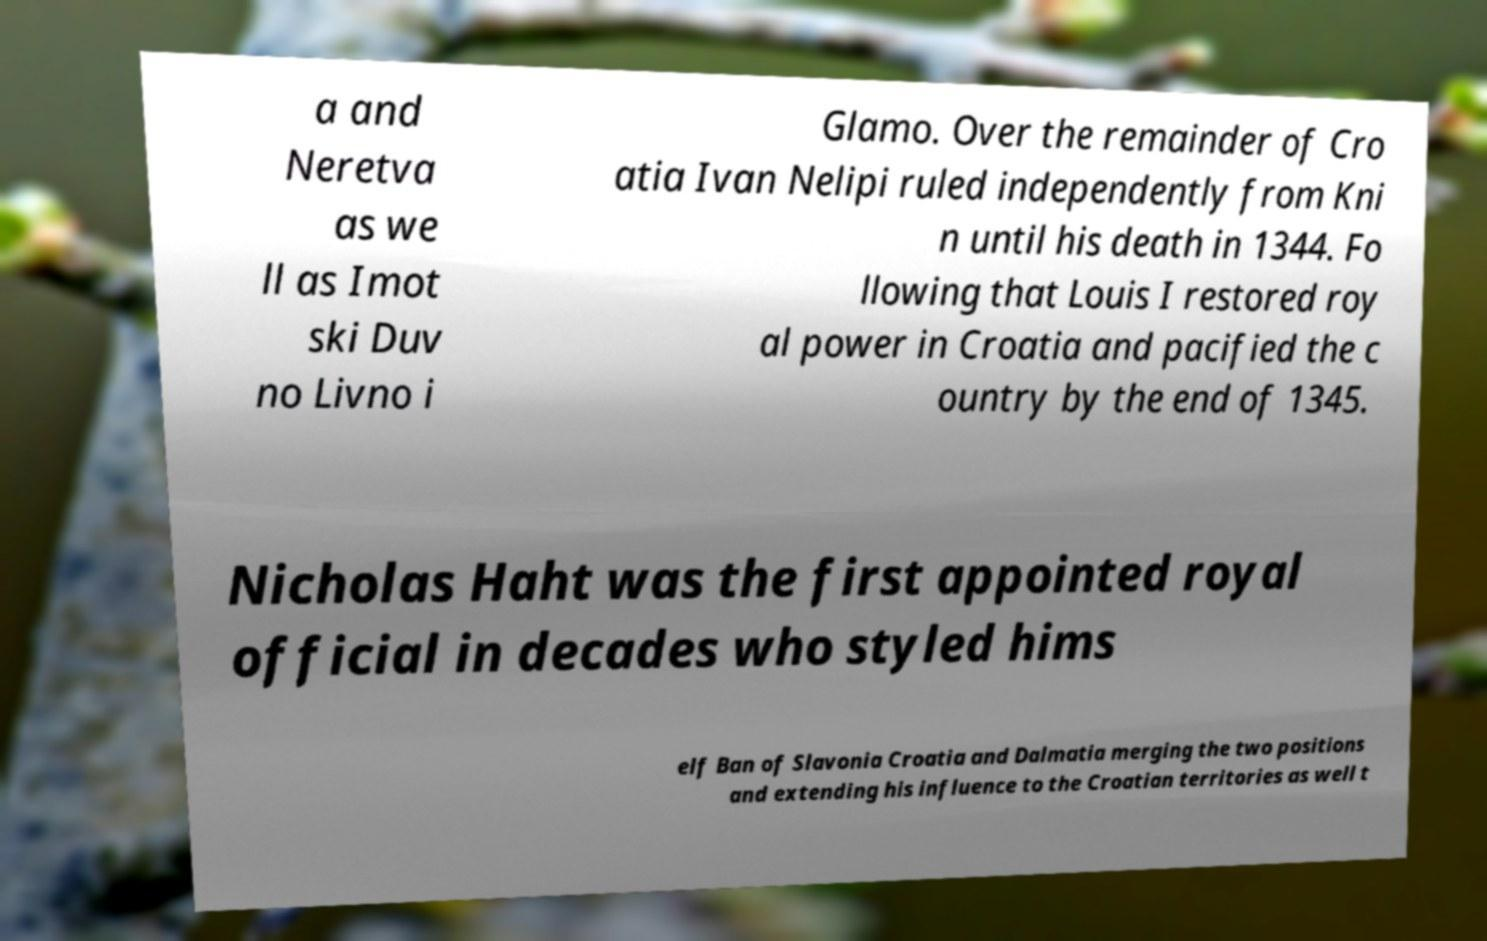Can you read and provide the text displayed in the image?This photo seems to have some interesting text. Can you extract and type it out for me? a and Neretva as we ll as Imot ski Duv no Livno i Glamo. Over the remainder of Cro atia Ivan Nelipi ruled independently from Kni n until his death in 1344. Fo llowing that Louis I restored roy al power in Croatia and pacified the c ountry by the end of 1345. Nicholas Haht was the first appointed royal official in decades who styled hims elf Ban of Slavonia Croatia and Dalmatia merging the two positions and extending his influence to the Croatian territories as well t 